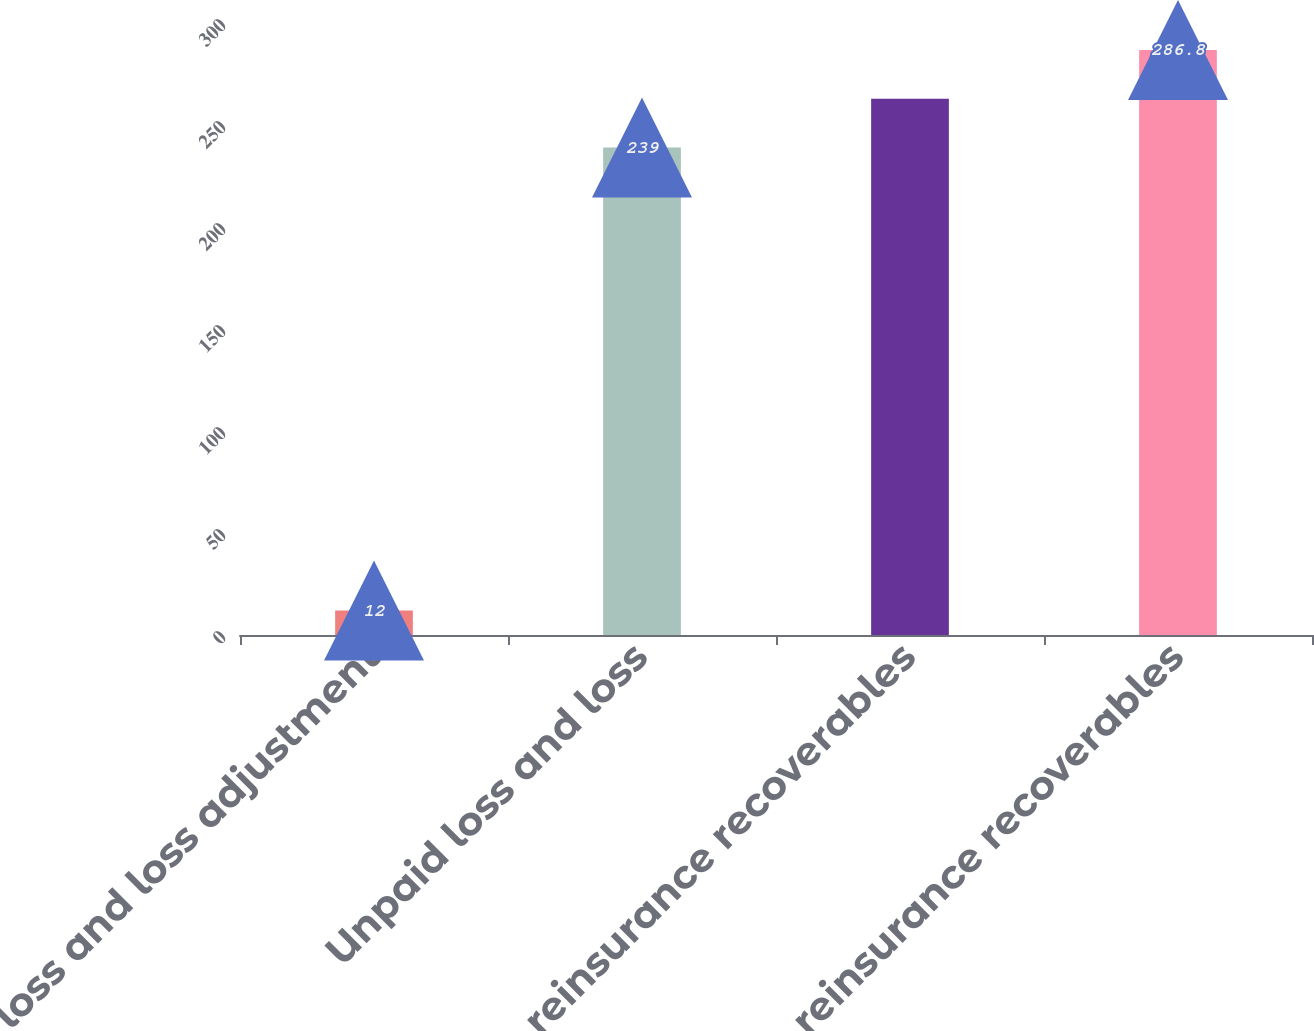Convert chart. <chart><loc_0><loc_0><loc_500><loc_500><bar_chart><fcel>Paid loss and loss adjustment<fcel>Unpaid loss and loss<fcel>Gross reinsurance recoverables<fcel>Net reinsurance recoverables<nl><fcel>12<fcel>239<fcel>262.9<fcel>286.8<nl></chart> 